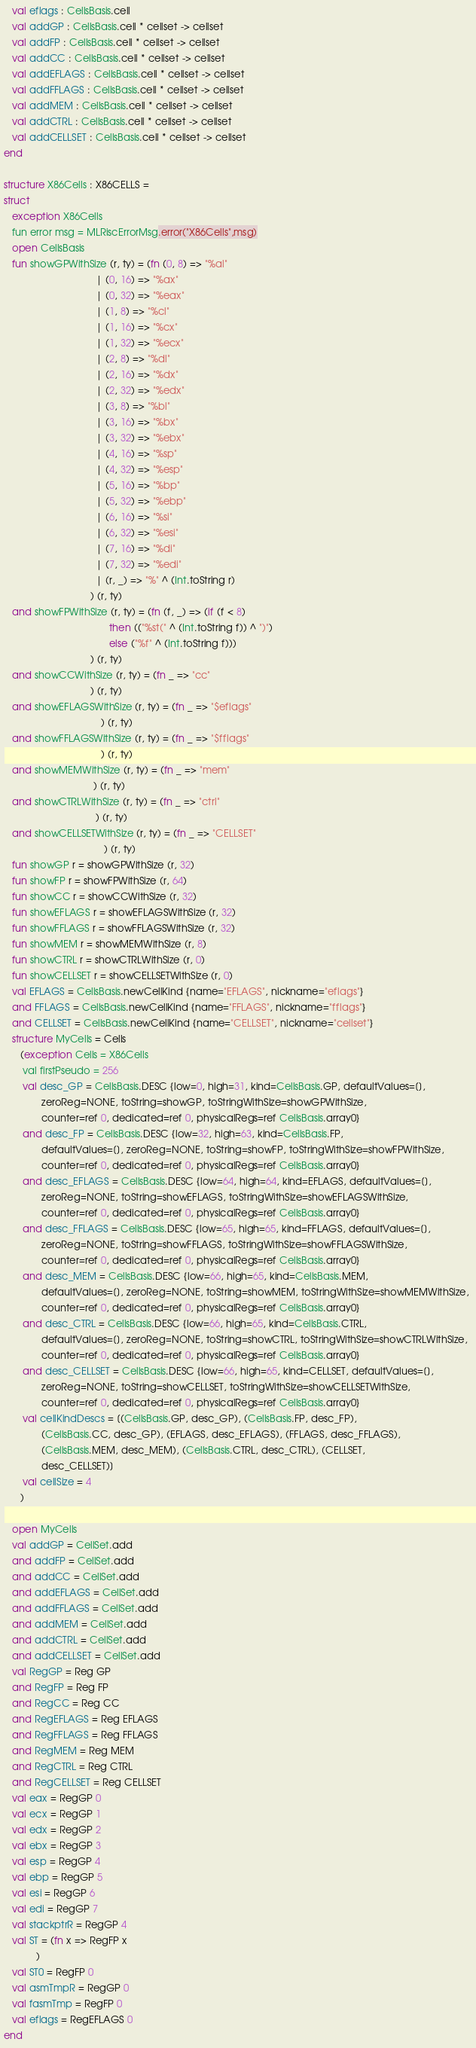Convert code to text. <code><loc_0><loc_0><loc_500><loc_500><_SML_>   val eflags : CellsBasis.cell
   val addGP : CellsBasis.cell * cellset -> cellset
   val addFP : CellsBasis.cell * cellset -> cellset
   val addCC : CellsBasis.cell * cellset -> cellset
   val addEFLAGS : CellsBasis.cell * cellset -> cellset
   val addFFLAGS : CellsBasis.cell * cellset -> cellset
   val addMEM : CellsBasis.cell * cellset -> cellset
   val addCTRL : CellsBasis.cell * cellset -> cellset
   val addCELLSET : CellsBasis.cell * cellset -> cellset
end

structure X86Cells : X86CELLS =
struct
   exception X86Cells
   fun error msg = MLRiscErrorMsg.error("X86Cells",msg)
   open CellsBasis
   fun showGPWithSize (r, ty) = (fn (0, 8) => "%al"
                                  | (0, 16) => "%ax"
                                  | (0, 32) => "%eax"
                                  | (1, 8) => "%cl"
                                  | (1, 16) => "%cx"
                                  | (1, 32) => "%ecx"
                                  | (2, 8) => "%dl"
                                  | (2, 16) => "%dx"
                                  | (2, 32) => "%edx"
                                  | (3, 8) => "%bl"
                                  | (3, 16) => "%bx"
                                  | (3, 32) => "%ebx"
                                  | (4, 16) => "%sp"
                                  | (4, 32) => "%esp"
                                  | (5, 16) => "%bp"
                                  | (5, 32) => "%ebp"
                                  | (6, 16) => "%si"
                                  | (6, 32) => "%esi"
                                  | (7, 16) => "%di"
                                  | (7, 32) => "%edi"
                                  | (r, _) => "%" ^ (Int.toString r)
                                ) (r, ty)
   and showFPWithSize (r, ty) = (fn (f, _) => (if (f < 8)
                                       then (("%st(" ^ (Int.toString f)) ^ ")")
                                       else ("%f" ^ (Int.toString f)))
                                ) (r, ty)
   and showCCWithSize (r, ty) = (fn _ => "cc"
                                ) (r, ty)
   and showEFLAGSWithSize (r, ty) = (fn _ => "$eflags"
                                    ) (r, ty)
   and showFFLAGSWithSize (r, ty) = (fn _ => "$fflags"
                                    ) (r, ty)
   and showMEMWithSize (r, ty) = (fn _ => "mem"
                                 ) (r, ty)
   and showCTRLWithSize (r, ty) = (fn _ => "ctrl"
                                  ) (r, ty)
   and showCELLSETWithSize (r, ty) = (fn _ => "CELLSET"
                                     ) (r, ty)
   fun showGP r = showGPWithSize (r, 32)
   fun showFP r = showFPWithSize (r, 64)
   fun showCC r = showCCWithSize (r, 32)
   fun showEFLAGS r = showEFLAGSWithSize (r, 32)
   fun showFFLAGS r = showFFLAGSWithSize (r, 32)
   fun showMEM r = showMEMWithSize (r, 8)
   fun showCTRL r = showCTRLWithSize (r, 0)
   fun showCELLSET r = showCELLSETWithSize (r, 0)
   val EFLAGS = CellsBasis.newCellKind {name="EFLAGS", nickname="eflags"}
   and FFLAGS = CellsBasis.newCellKind {name="FFLAGS", nickname="fflags"}
   and CELLSET = CellsBasis.newCellKind {name="CELLSET", nickname="cellset"}
   structure MyCells = Cells
      (exception Cells = X86Cells
       val firstPseudo = 256
       val desc_GP = CellsBasis.DESC {low=0, high=31, kind=CellsBasis.GP, defaultValues=[], 
              zeroReg=NONE, toString=showGP, toStringWithSize=showGPWithSize, 
              counter=ref 0, dedicated=ref 0, physicalRegs=ref CellsBasis.array0}
       and desc_FP = CellsBasis.DESC {low=32, high=63, kind=CellsBasis.FP, 
              defaultValues=[], zeroReg=NONE, toString=showFP, toStringWithSize=showFPWithSize, 
              counter=ref 0, dedicated=ref 0, physicalRegs=ref CellsBasis.array0}
       and desc_EFLAGS = CellsBasis.DESC {low=64, high=64, kind=EFLAGS, defaultValues=[], 
              zeroReg=NONE, toString=showEFLAGS, toStringWithSize=showEFLAGSWithSize, 
              counter=ref 0, dedicated=ref 0, physicalRegs=ref CellsBasis.array0}
       and desc_FFLAGS = CellsBasis.DESC {low=65, high=65, kind=FFLAGS, defaultValues=[], 
              zeroReg=NONE, toString=showFFLAGS, toStringWithSize=showFFLAGSWithSize, 
              counter=ref 0, dedicated=ref 0, physicalRegs=ref CellsBasis.array0}
       and desc_MEM = CellsBasis.DESC {low=66, high=65, kind=CellsBasis.MEM, 
              defaultValues=[], zeroReg=NONE, toString=showMEM, toStringWithSize=showMEMWithSize, 
              counter=ref 0, dedicated=ref 0, physicalRegs=ref CellsBasis.array0}
       and desc_CTRL = CellsBasis.DESC {low=66, high=65, kind=CellsBasis.CTRL, 
              defaultValues=[], zeroReg=NONE, toString=showCTRL, toStringWithSize=showCTRLWithSize, 
              counter=ref 0, dedicated=ref 0, physicalRegs=ref CellsBasis.array0}
       and desc_CELLSET = CellsBasis.DESC {low=66, high=65, kind=CELLSET, defaultValues=[], 
              zeroReg=NONE, toString=showCELLSET, toStringWithSize=showCELLSETWithSize, 
              counter=ref 0, dedicated=ref 0, physicalRegs=ref CellsBasis.array0}
       val cellKindDescs = [(CellsBasis.GP, desc_GP), (CellsBasis.FP, desc_FP), 
              (CellsBasis.CC, desc_GP), (EFLAGS, desc_EFLAGS), (FFLAGS, desc_FFLAGS), 
              (CellsBasis.MEM, desc_MEM), (CellsBasis.CTRL, desc_CTRL), (CELLSET, 
              desc_CELLSET)]
       val cellSize = 4
      )

   open MyCells
   val addGP = CellSet.add
   and addFP = CellSet.add
   and addCC = CellSet.add
   and addEFLAGS = CellSet.add
   and addFFLAGS = CellSet.add
   and addMEM = CellSet.add
   and addCTRL = CellSet.add
   and addCELLSET = CellSet.add
   val RegGP = Reg GP
   and RegFP = Reg FP
   and RegCC = Reg CC
   and RegEFLAGS = Reg EFLAGS
   and RegFFLAGS = Reg FFLAGS
   and RegMEM = Reg MEM
   and RegCTRL = Reg CTRL
   and RegCELLSET = Reg CELLSET
   val eax = RegGP 0
   val ecx = RegGP 1
   val edx = RegGP 2
   val ebx = RegGP 3
   val esp = RegGP 4
   val ebp = RegGP 5
   val esi = RegGP 6
   val edi = RegGP 7
   val stackptrR = RegGP 4
   val ST = (fn x => RegFP x
            )
   val ST0 = RegFP 0
   val asmTmpR = RegGP 0
   val fasmTmp = RegFP 0
   val eflags = RegEFLAGS 0
end

</code> 